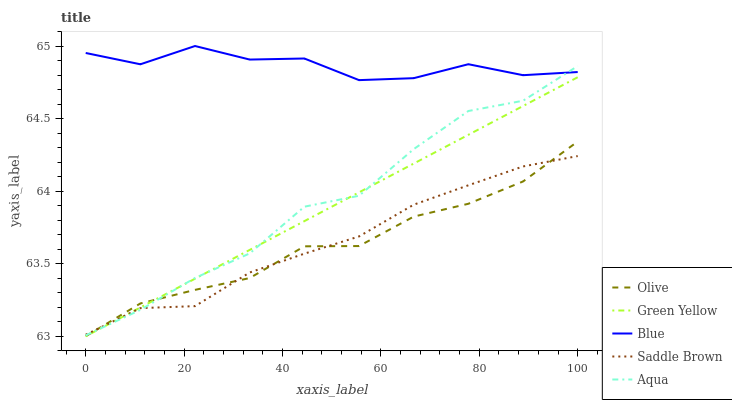Does Olive have the minimum area under the curve?
Answer yes or no. Yes. Does Blue have the maximum area under the curve?
Answer yes or no. Yes. Does Green Yellow have the minimum area under the curve?
Answer yes or no. No. Does Green Yellow have the maximum area under the curve?
Answer yes or no. No. Is Green Yellow the smoothest?
Answer yes or no. Yes. Is Blue the roughest?
Answer yes or no. Yes. Is Blue the smoothest?
Answer yes or no. No. Is Green Yellow the roughest?
Answer yes or no. No. Does Olive have the lowest value?
Answer yes or no. Yes. Does Blue have the lowest value?
Answer yes or no. No. Does Blue have the highest value?
Answer yes or no. Yes. Does Green Yellow have the highest value?
Answer yes or no. No. Is Green Yellow less than Blue?
Answer yes or no. Yes. Is Blue greater than Green Yellow?
Answer yes or no. Yes. Does Blue intersect Aqua?
Answer yes or no. Yes. Is Blue less than Aqua?
Answer yes or no. No. Is Blue greater than Aqua?
Answer yes or no. No. Does Green Yellow intersect Blue?
Answer yes or no. No. 